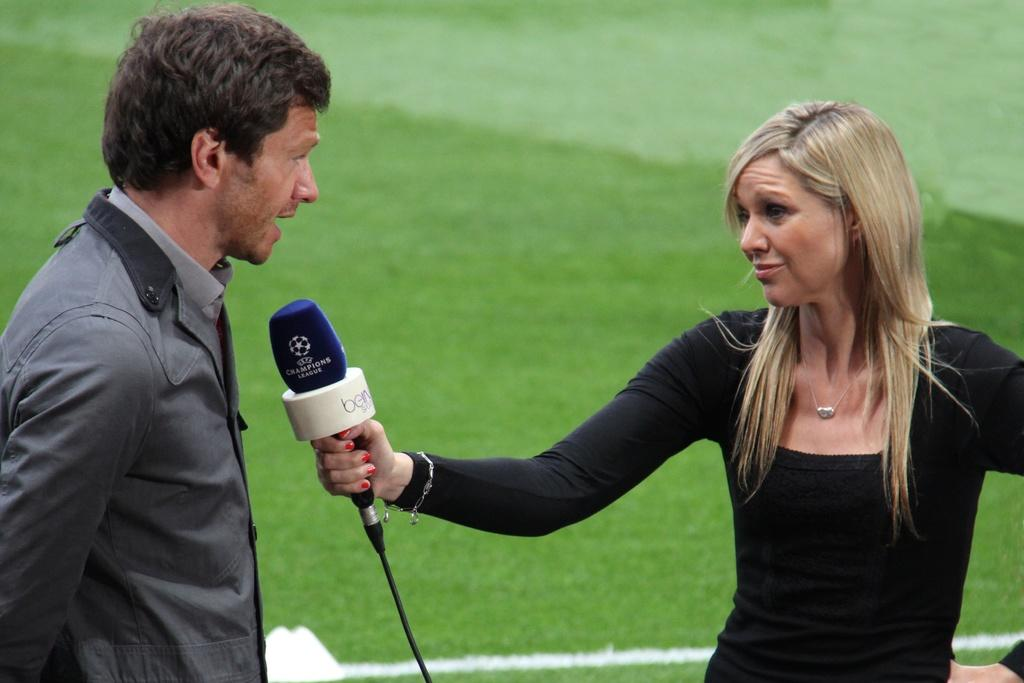Who are the people in the image? There is a man and a woman in the image. What are the man and woman doing in the image? The man and woman are standing in opposite directions. What is the woman holding in the image? The woman is holding a mic. What can be seen in the background of the image? There is grass visible in the background of the image. What type of tooth is visible in the image? There is no tooth visible in the image. What kind of bait is being used by the man in the image? There is no bait or fishing activity depicted in the image; the man is simply standing in a certain direction. 